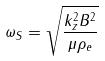<formula> <loc_0><loc_0><loc_500><loc_500>\omega _ { S } = \sqrt { \frac { k _ { z } ^ { 2 } B ^ { 2 } } { \mu \rho _ { e } } }</formula> 